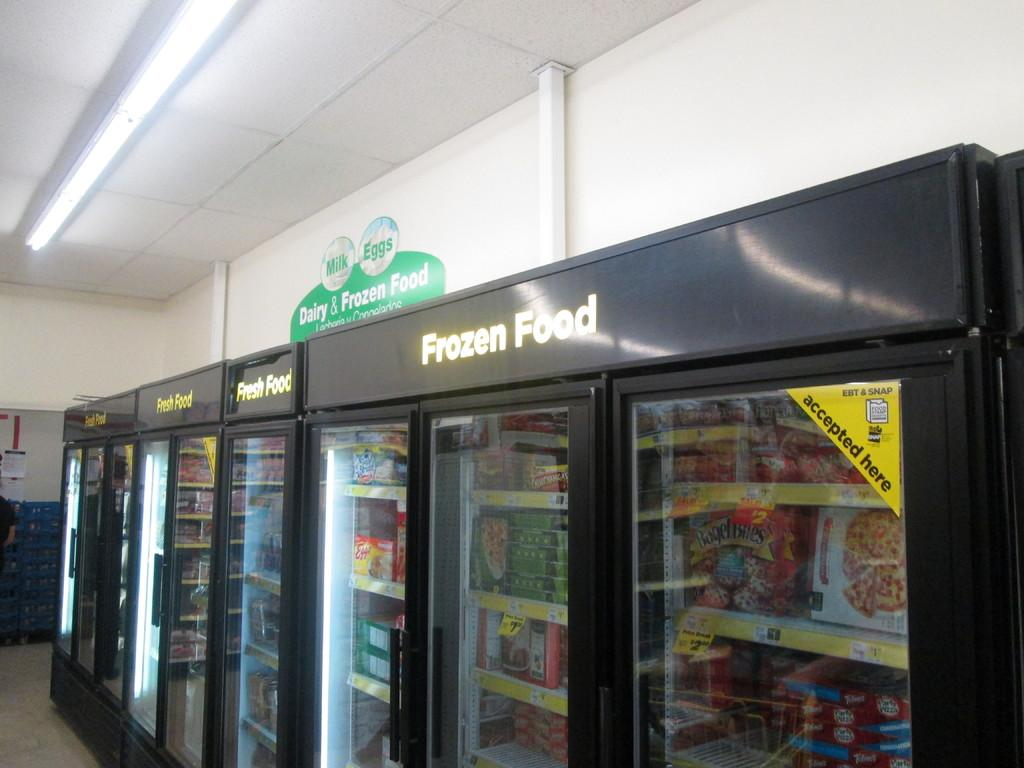Provide a one-sentence caption for the provided image. A frozen food sign hangs next to a fresh food sign. 